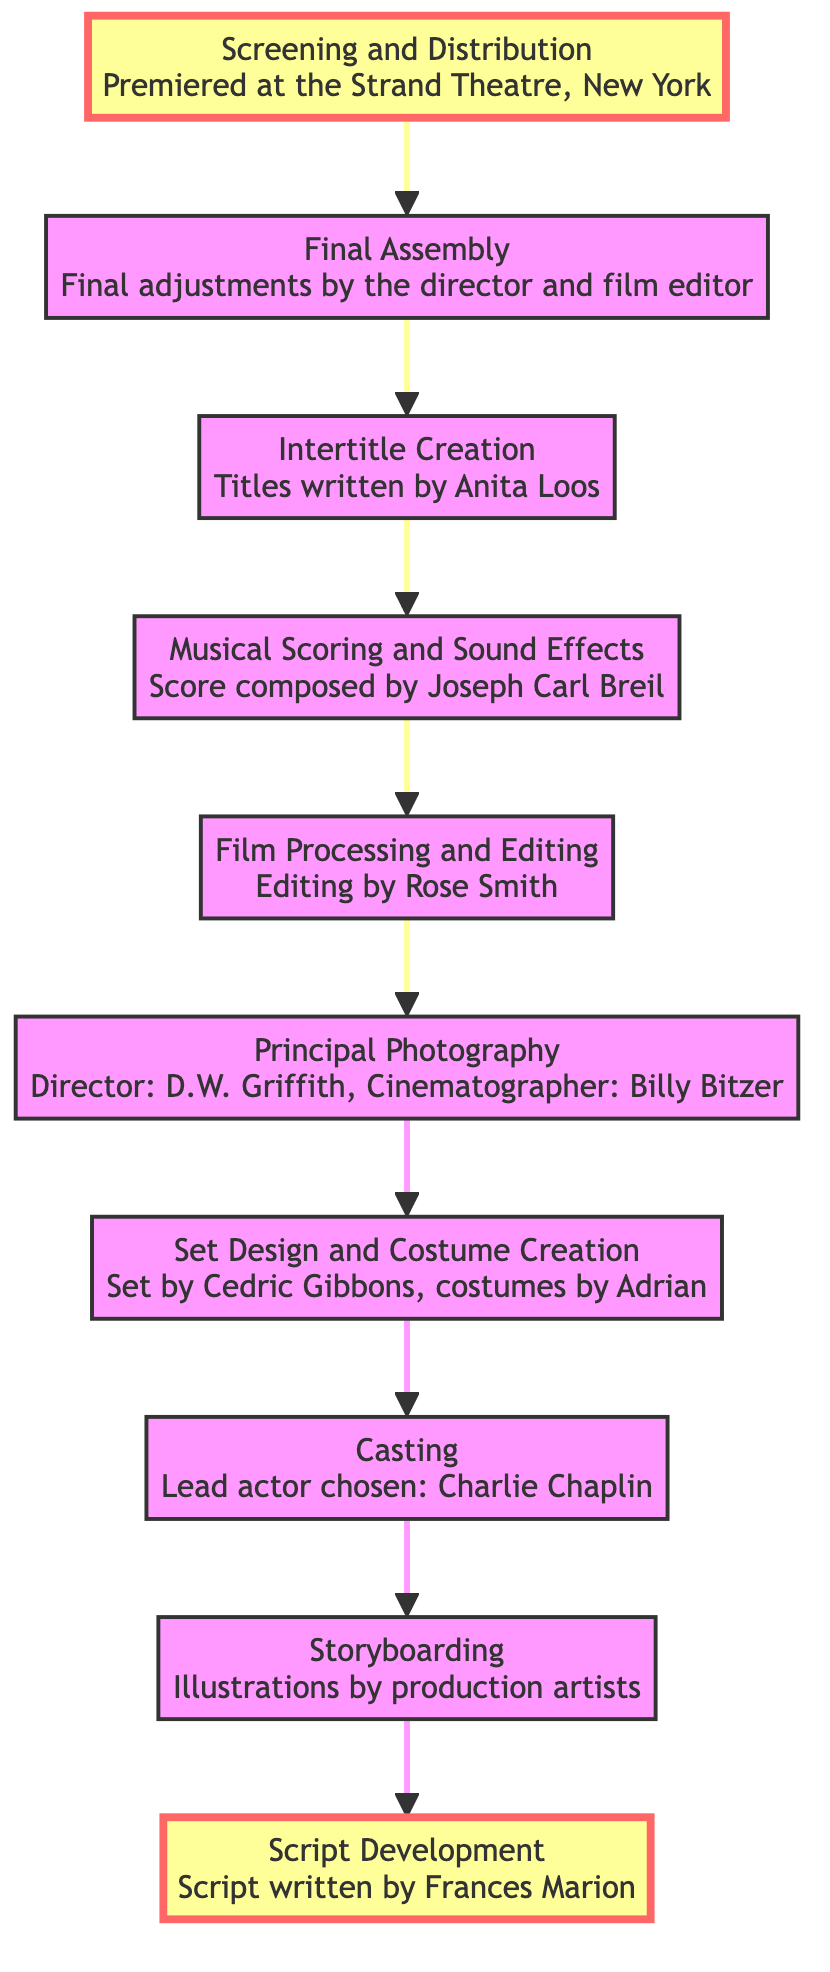What is the first step in the evolution of a silent film? The diagram indicates that the very first step is "Script Development". This can be identified as the node at the bottom of the flow.
Answer: Script Development How many total steps are indicated in the flow chart? By counting the nodes in the diagram, there are a total of 10 steps from "Script Development" to "Screening and Distribution".
Answer: 10 What comes directly after "Set Design and Costume Creation"? In the flow chart, the step immediately following "Set Design and Costume Creation" is "Principal Photography". You can identify this by moving up one node from "Set Design and Costume Creation".
Answer: Principal Photography Who wrote the score for the film? The corresponding node for the step "Musical Scoring and Sound Effects" states it was composed by "Joseph Carl Breil", indicated within the diagram.
Answer: Joseph Carl Breil What is the relationship between "Intertitle Creation" and "Final Assembly"? In the flow chart, "Intertitle Creation" comes directly before "Final Assembly", indicating a sequential relationship where intertitles are created before the final film print is assembled.
Answer: Sequential What type of adjustments are made in the "Final Assembly"? The description for "Final Assembly" indicates "Final adjustments by the director and film editor", providing a clear identity of the adjustments made at this stage.
Answer: Final adjustments What step precedes "Casting"? The step right before "Casting" in the diagram is "Storyboarding". By examining the flow of operations, one can see that Storyboarding is the preparatory step before selecting actors.
Answer: Storyboarding How is the film's era matched in production? The diagram indicates that "Set Design and Costume Creation" match the film’s era and style, evidencing that this step is crucial in aligning production with the intended time period.
Answer: Set Design and Costume Creation Where does "Screening and Distribution" fit in the overall evolution? "Screening and Distribution" is the final step in the diagram, indicating it is the last action taken after all other elements are completed, leading to the film being shown to audiences.
Answer: Final step 